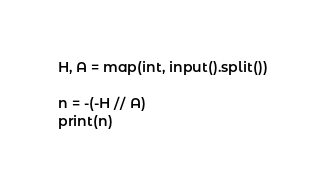Convert code to text. <code><loc_0><loc_0><loc_500><loc_500><_Python_>H, A = map(int, input().split())

n = -(-H // A)
print(n)</code> 